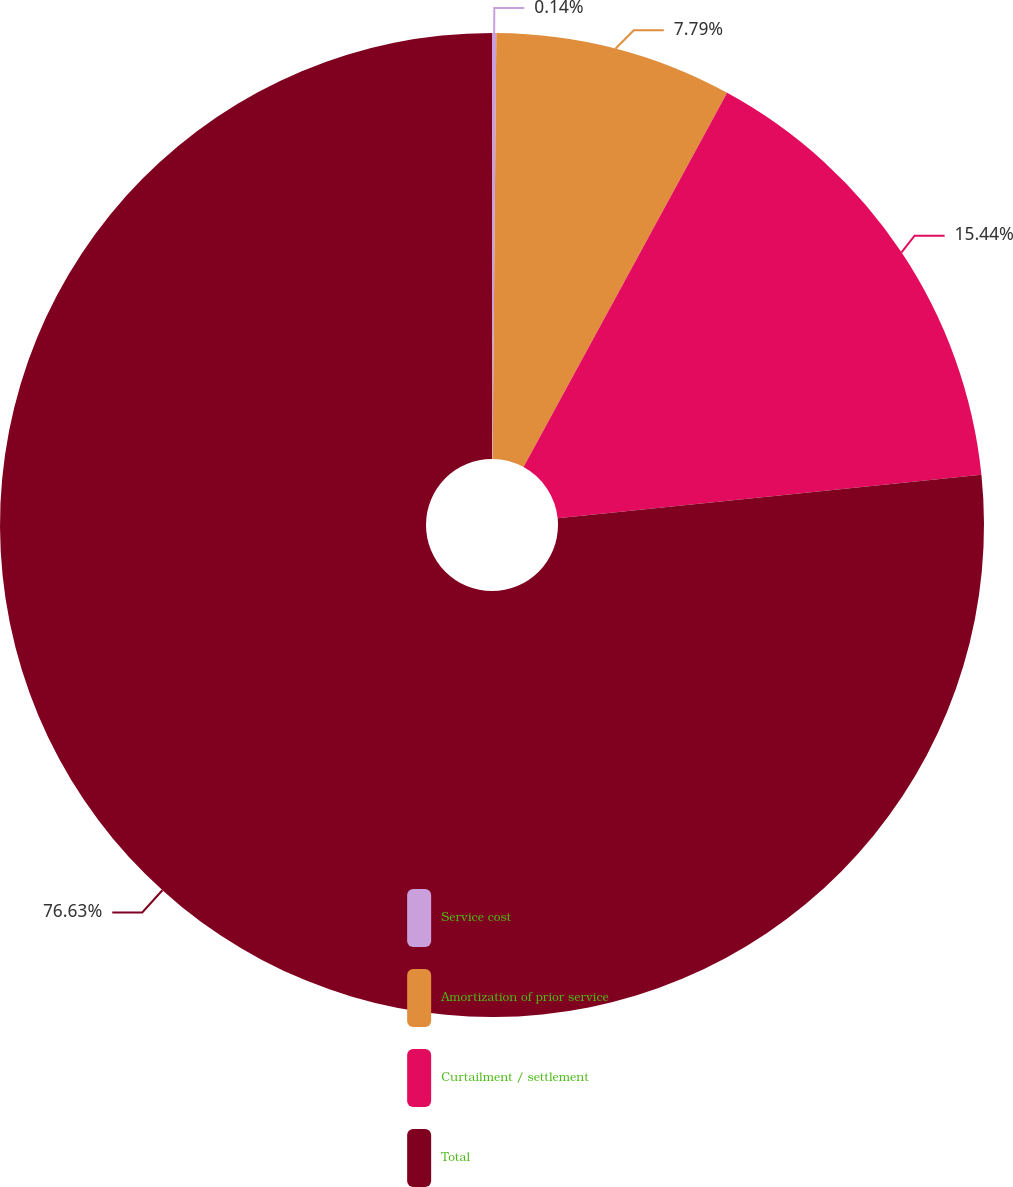Convert chart to OTSL. <chart><loc_0><loc_0><loc_500><loc_500><pie_chart><fcel>Service cost<fcel>Amortization of prior service<fcel>Curtailment / settlement<fcel>Total<nl><fcel>0.14%<fcel>7.79%<fcel>15.44%<fcel>76.63%<nl></chart> 